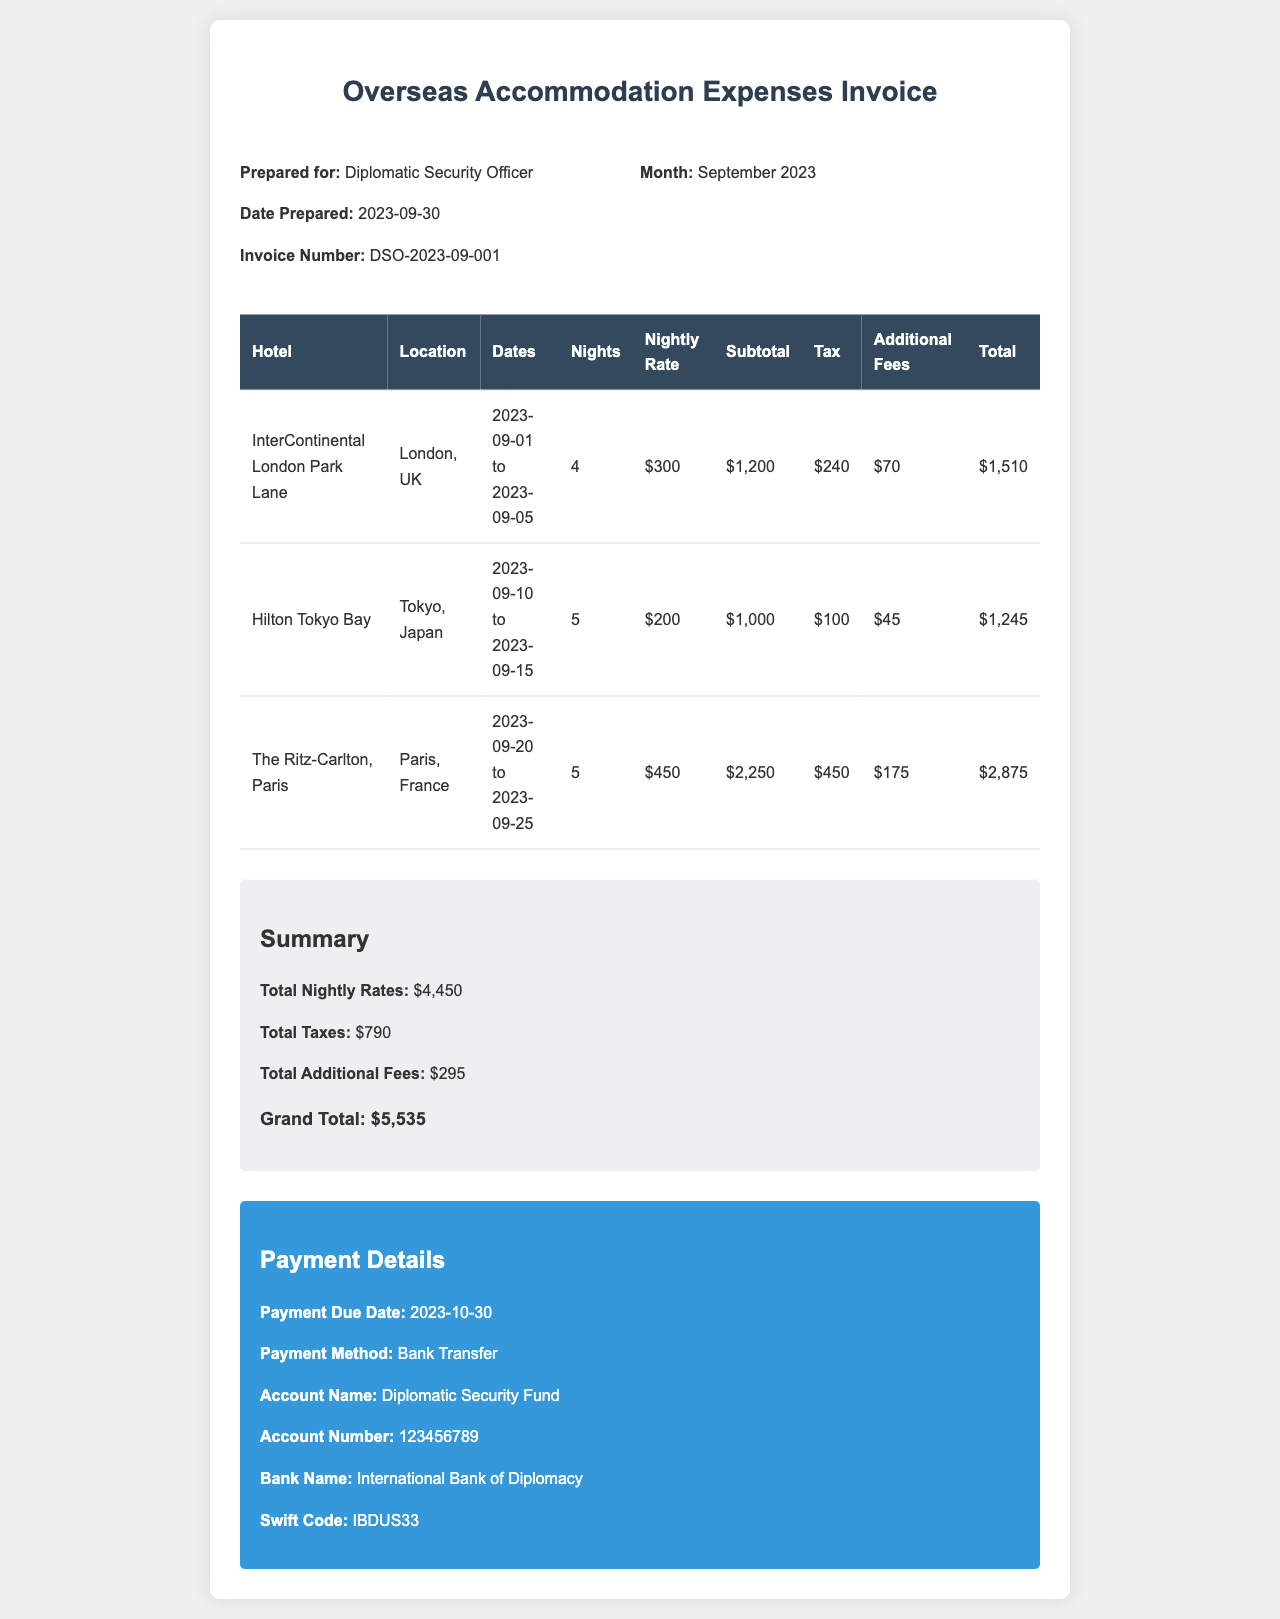What is the invoice number? The invoice number is listed at the top of the document under the header section.
Answer: DSO-2023-09-001 What hotel is located in Paris? The hotel listed in Paris is mentioned in the table of accommodation expenses.
Answer: The Ritz-Carlton, Paris How many nights did the stay in Tokyo last? The number of nights for the Tokyo stay is found in the corresponding table row.
Answer: 5 What is the total tax amount? The total tax amount is summarized in the document's summary section.
Answer: $790 What is the nightly rate for the hotel in London? The nightly rate for the London hotel is specified in the table associated with that hotel.
Answer: $300 What is the grand total for all accommodation expenses? The grand total is calculated based on the summary of all listed expenses and found at the end of the summary section.
Answer: $5,535 What date is the payment due? The payment due date is mentioned in the payment details section of the document.
Answer: 2023-10-30 What payment method is specified? The payment method is outlined in the payment details section of the document.
Answer: Bank Transfer How much were the additional fees for the Paris hotel? The additional fees for the Paris hotel can be found in its respective row of the expense table.
Answer: $175 